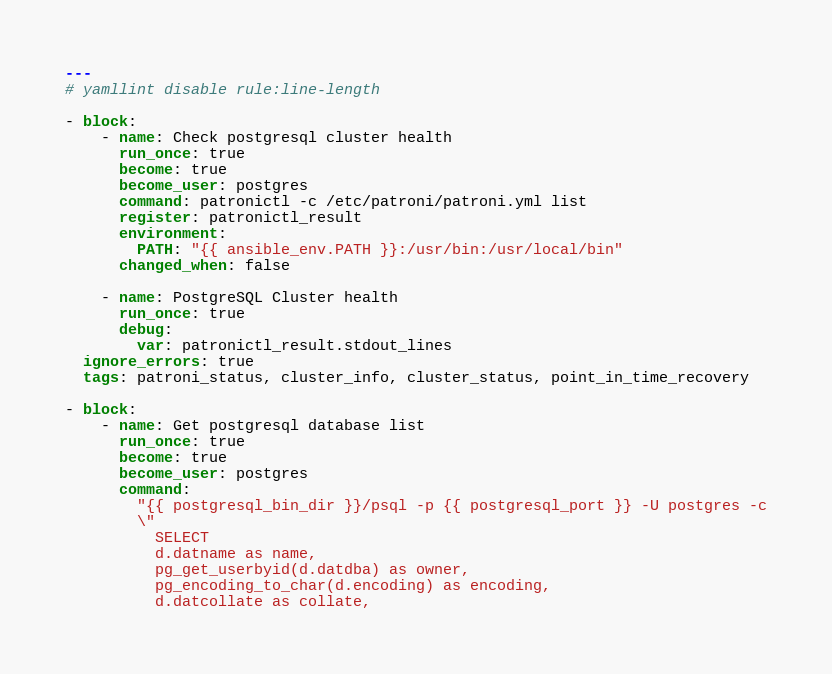Convert code to text. <code><loc_0><loc_0><loc_500><loc_500><_YAML_>---
# yamllint disable rule:line-length

- block:
    - name: Check postgresql cluster health
      run_once: true
      become: true
      become_user: postgres
      command: patronictl -c /etc/patroni/patroni.yml list
      register: patronictl_result
      environment:
        PATH: "{{ ansible_env.PATH }}:/usr/bin:/usr/local/bin"
      changed_when: false

    - name: PostgreSQL Cluster health
      run_once: true
      debug:
        var: patronictl_result.stdout_lines
  ignore_errors: true
  tags: patroni_status, cluster_info, cluster_status, point_in_time_recovery

- block:
    - name: Get postgresql database list
      run_once: true
      become: true
      become_user: postgres
      command:
        "{{ postgresql_bin_dir }}/psql -p {{ postgresql_port }} -U postgres -c
        \"
          SELECT
          d.datname as name,
          pg_get_userbyid(d.datdba) as owner,
          pg_encoding_to_char(d.encoding) as encoding,
          d.datcollate as collate,</code> 